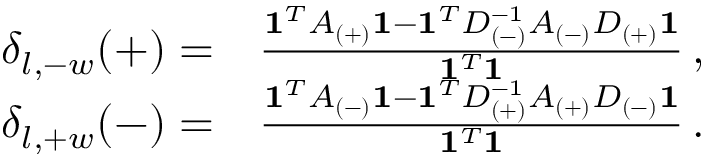<formula> <loc_0><loc_0><loc_500><loc_500>\begin{array} { r l } { \delta _ { l , - w } ( + ) = } & \frac { 1 ^ { T } A _ { ( + ) } 1 - 1 ^ { T } D _ { ( - ) } ^ { - 1 } A _ { ( - ) } D _ { ( + ) } 1 } { 1 ^ { T } 1 } \, , } \\ { \delta _ { l , + w } ( - ) = } & \frac { 1 ^ { T } A _ { ( - ) } 1 - 1 ^ { T } D _ { ( + ) } ^ { - 1 } A _ { ( + ) } D _ { ( - ) } 1 } { 1 ^ { T } 1 } \, . } \end{array}</formula> 